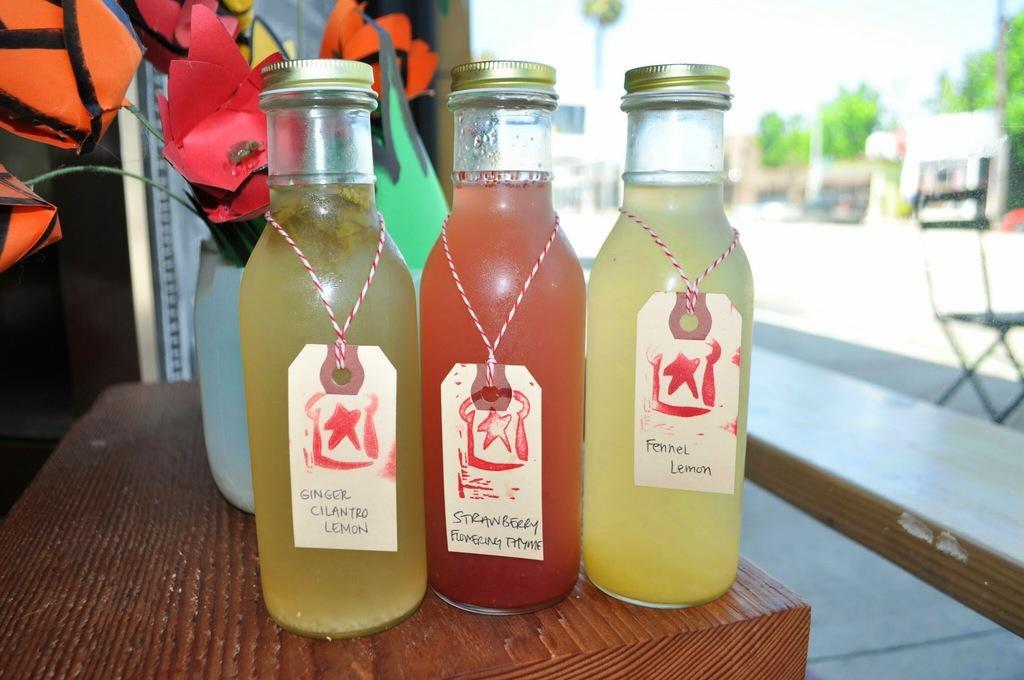Please provide a concise description of this image. As we can see in the image there is a table. On table there are bottles and flower flask. 